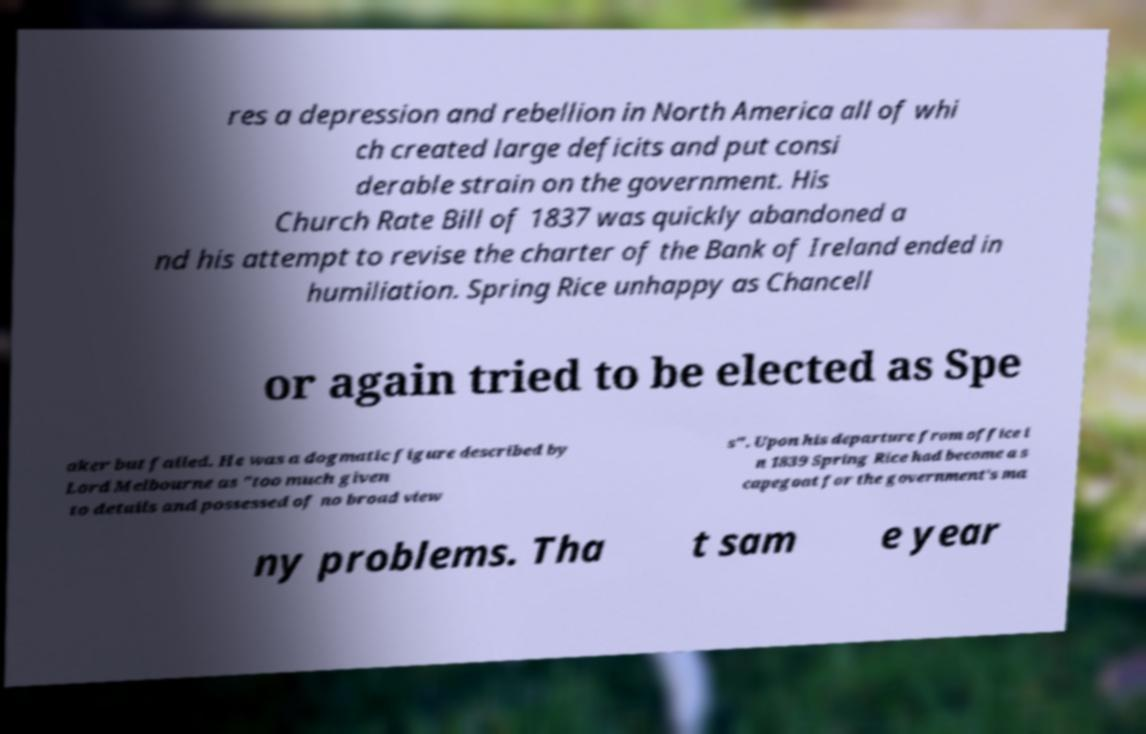I need the written content from this picture converted into text. Can you do that? res a depression and rebellion in North America all of whi ch created large deficits and put consi derable strain on the government. His Church Rate Bill of 1837 was quickly abandoned a nd his attempt to revise the charter of the Bank of Ireland ended in humiliation. Spring Rice unhappy as Chancell or again tried to be elected as Spe aker but failed. He was a dogmatic figure described by Lord Melbourne as "too much given to details and possessed of no broad view s". Upon his departure from office i n 1839 Spring Rice had become a s capegoat for the government's ma ny problems. Tha t sam e year 